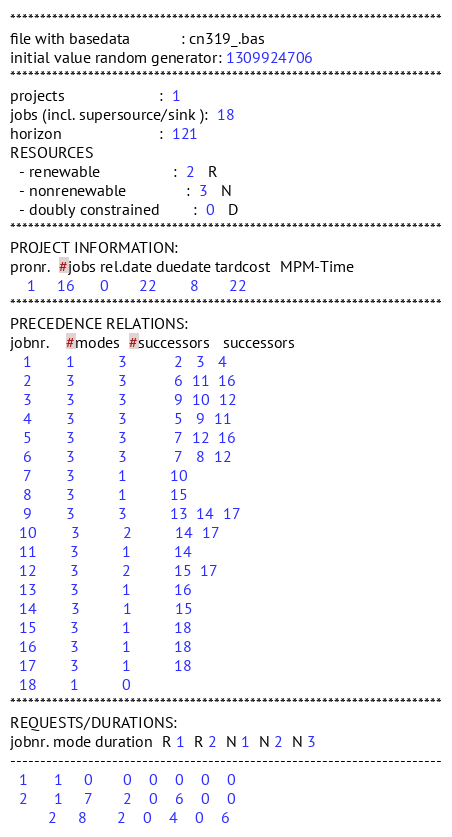Convert code to text. <code><loc_0><loc_0><loc_500><loc_500><_ObjectiveC_>************************************************************************
file with basedata            : cn319_.bas
initial value random generator: 1309924706
************************************************************************
projects                      :  1
jobs (incl. supersource/sink ):  18
horizon                       :  121
RESOURCES
  - renewable                 :  2   R
  - nonrenewable              :  3   N
  - doubly constrained        :  0   D
************************************************************************
PROJECT INFORMATION:
pronr.  #jobs rel.date duedate tardcost  MPM-Time
    1     16      0       22        8       22
************************************************************************
PRECEDENCE RELATIONS:
jobnr.    #modes  #successors   successors
   1        1          3           2   3   4
   2        3          3           6  11  16
   3        3          3           9  10  12
   4        3          3           5   9  11
   5        3          3           7  12  16
   6        3          3           7   8  12
   7        3          1          10
   8        3          1          15
   9        3          3          13  14  17
  10        3          2          14  17
  11        3          1          14
  12        3          2          15  17
  13        3          1          16
  14        3          1          15
  15        3          1          18
  16        3          1          18
  17        3          1          18
  18        1          0        
************************************************************************
REQUESTS/DURATIONS:
jobnr. mode duration  R 1  R 2  N 1  N 2  N 3
------------------------------------------------------------------------
  1      1     0       0    0    0    0    0
  2      1     7       2    0    6    0    0
         2     8       2    0    4    0    6</code> 